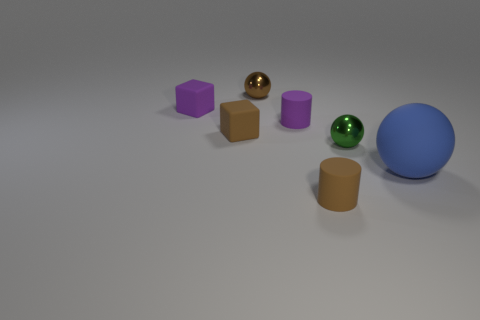Add 3 small objects. How many objects exist? 10 Subtract all blocks. How many objects are left? 5 Add 1 blue balls. How many blue balls exist? 2 Subtract 1 brown balls. How many objects are left? 6 Subtract all purple cylinders. Subtract all tiny brown objects. How many objects are left? 3 Add 1 rubber objects. How many rubber objects are left? 6 